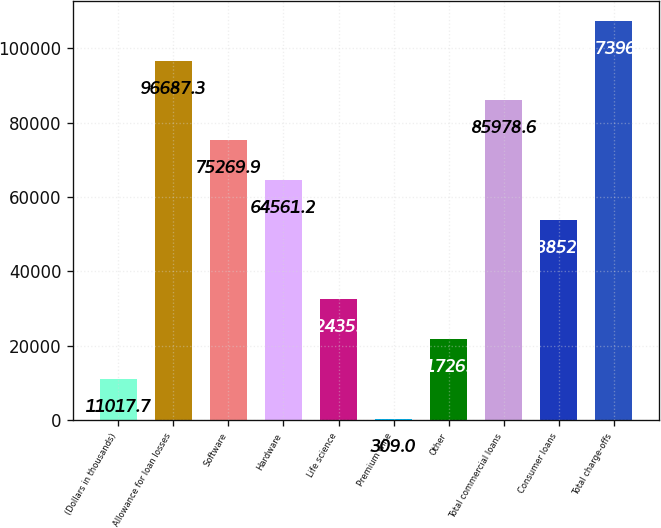Convert chart to OTSL. <chart><loc_0><loc_0><loc_500><loc_500><bar_chart><fcel>(Dollars in thousands)<fcel>Allowance for loan losses<fcel>Software<fcel>Hardware<fcel>Life science<fcel>Premium wine<fcel>Other<fcel>Total commercial loans<fcel>Consumer loans<fcel>Total charge-offs<nl><fcel>11017.7<fcel>96687.3<fcel>75269.9<fcel>64561.2<fcel>32435.1<fcel>309<fcel>21726.4<fcel>85978.6<fcel>53852.5<fcel>107396<nl></chart> 